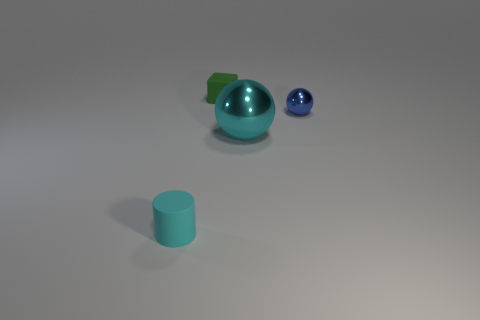Are there any other things that are the same size as the cyan metallic ball?
Make the answer very short. No. There is a big thing that is to the left of the blue shiny sphere; does it have the same shape as the small green rubber thing?
Provide a short and direct response. No. Is the number of large gray rubber balls less than the number of green matte things?
Offer a terse response. Yes. There is a cylinder that is the same size as the green rubber cube; what material is it?
Your answer should be very brief. Rubber. Do the big ball and the small matte object in front of the blue shiny thing have the same color?
Provide a succinct answer. Yes. Is the number of small cylinders left of the small metallic ball less than the number of blue balls?
Provide a succinct answer. No. How many big green matte objects are there?
Your response must be concise. 0. There is a tiny thing to the right of the tiny matte thing that is behind the tiny cyan cylinder; what shape is it?
Offer a very short reply. Sphere. There is a tiny rubber cube; how many small green things are on the right side of it?
Your answer should be compact. 0. Is the large object made of the same material as the tiny object that is right of the big shiny ball?
Give a very brief answer. Yes. 